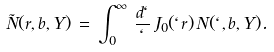Convert formula to latex. <formula><loc_0><loc_0><loc_500><loc_500>\tilde { N } ( r , b , Y ) \, = \, \int _ { 0 } ^ { \infty } \, \frac { d \ell } { \ell } \, J _ { 0 } ( \ell r ) \, N ( \ell , b , Y ) .</formula> 